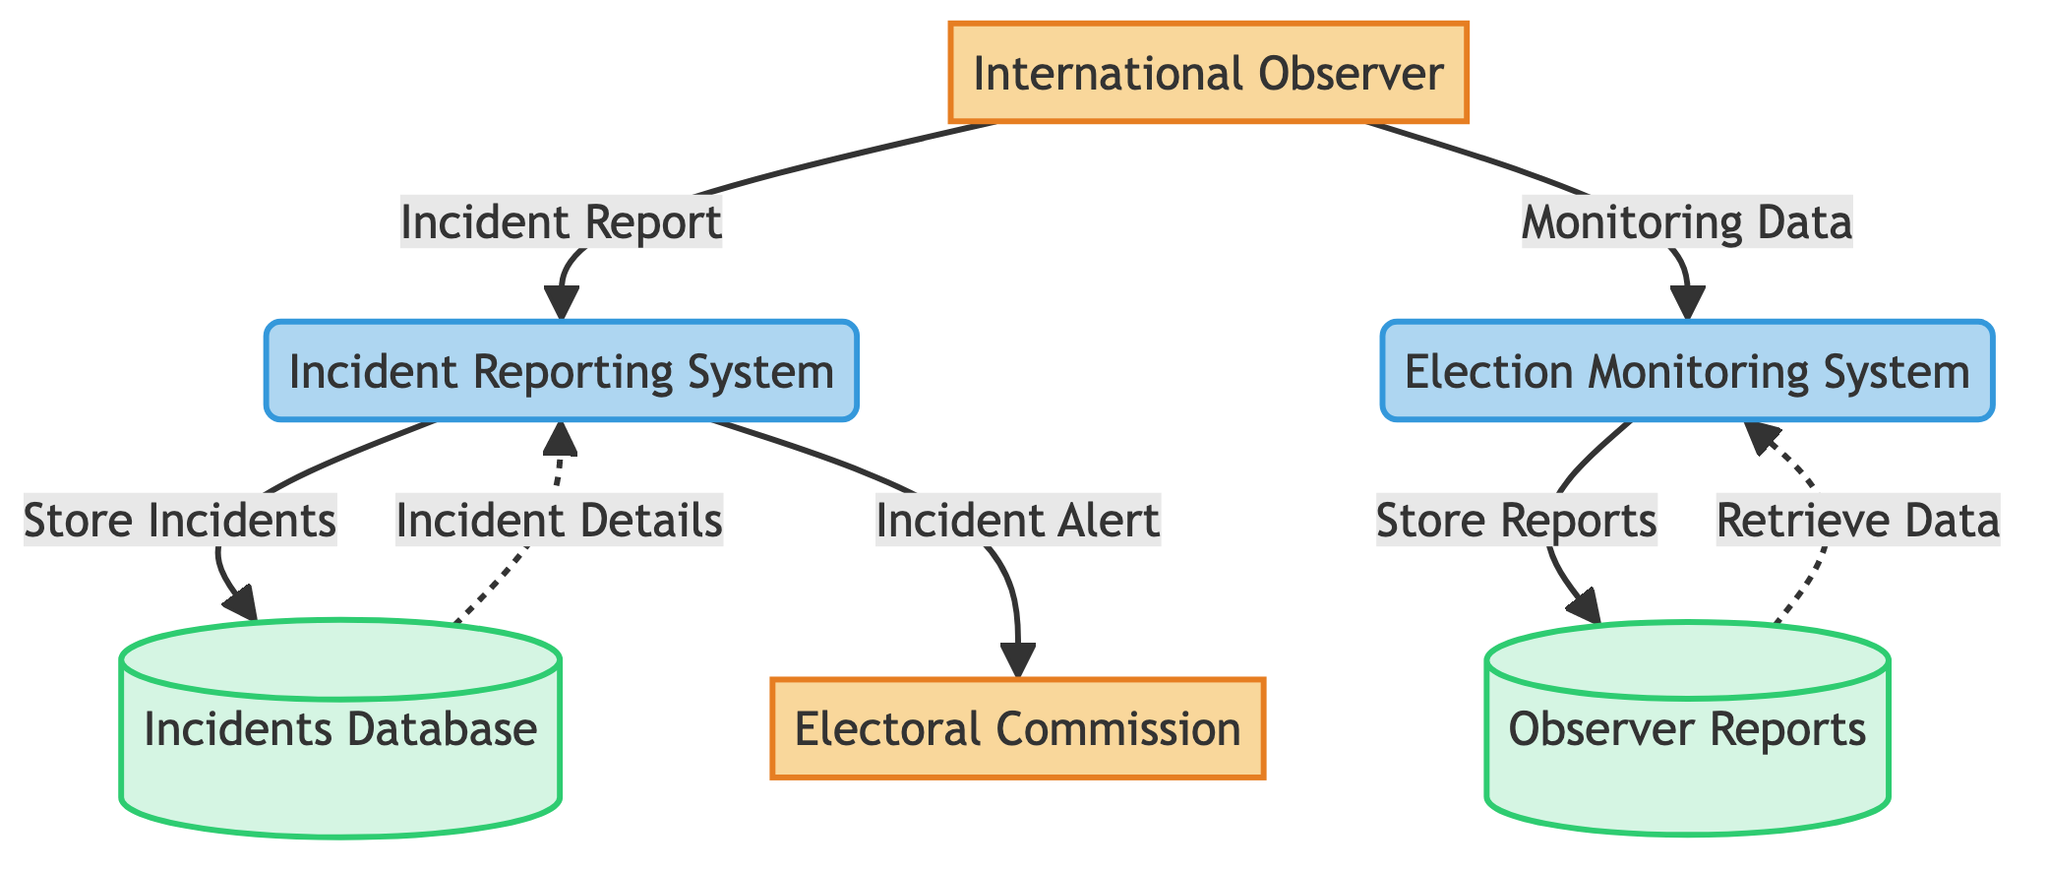What is the first entity in the diagram? The diagram starts with the International Observer entity, which is located on the left side and represents the individual monitoring the elections.
Answer: International Observer How many data flows are present in the diagram? By counting the arrows representing data flows, we find there are a total of 6 data flows connecting the entities and processes.
Answer: 6 What type of entity is the Electoral Commission? The Electoral Commission is categorized as an External Entity in the diagram, suggesting it operates outside the central system processes.
Answer: External Entity What does the Incident Reporting System do with the incidents? The Incident Reporting System is responsible for storing incidents in the Incidents Database according to the diagram.
Answer: Store Incidents Which data store is used to keep Observer Reports? The Observer Reports data store is specifically designated for storing reports created by international observers, as mentioned in the diagram.
Answer: Observer Reports What data flows from the Incident Reporting System to the Electoral Commission? The diagram indicates that the Incident Alert data flow originates from the Incident Reporting System and is directed toward the Electoral Commission.
Answer: Incident Alert What type of process is the Election Monitoring System? The Election Monitoring System is classified as a Process in the diagram, which indicates it engages in actions related to election activity monitoring.
Answer: Process Which external entity is involved in notifying the election-related incidents? According to the diagram, the notification concerning election-related incidents is sent to the Electoral Commission from the Incident Reporting System.
Answer: Electoral Commission How does the International Observer interact with the Election Monitoring System? The International Observer interacts with the Election Monitoring System by providing Monitoring Data, indicating their role in supporting the system with information.
Answer: Monitoring Data 